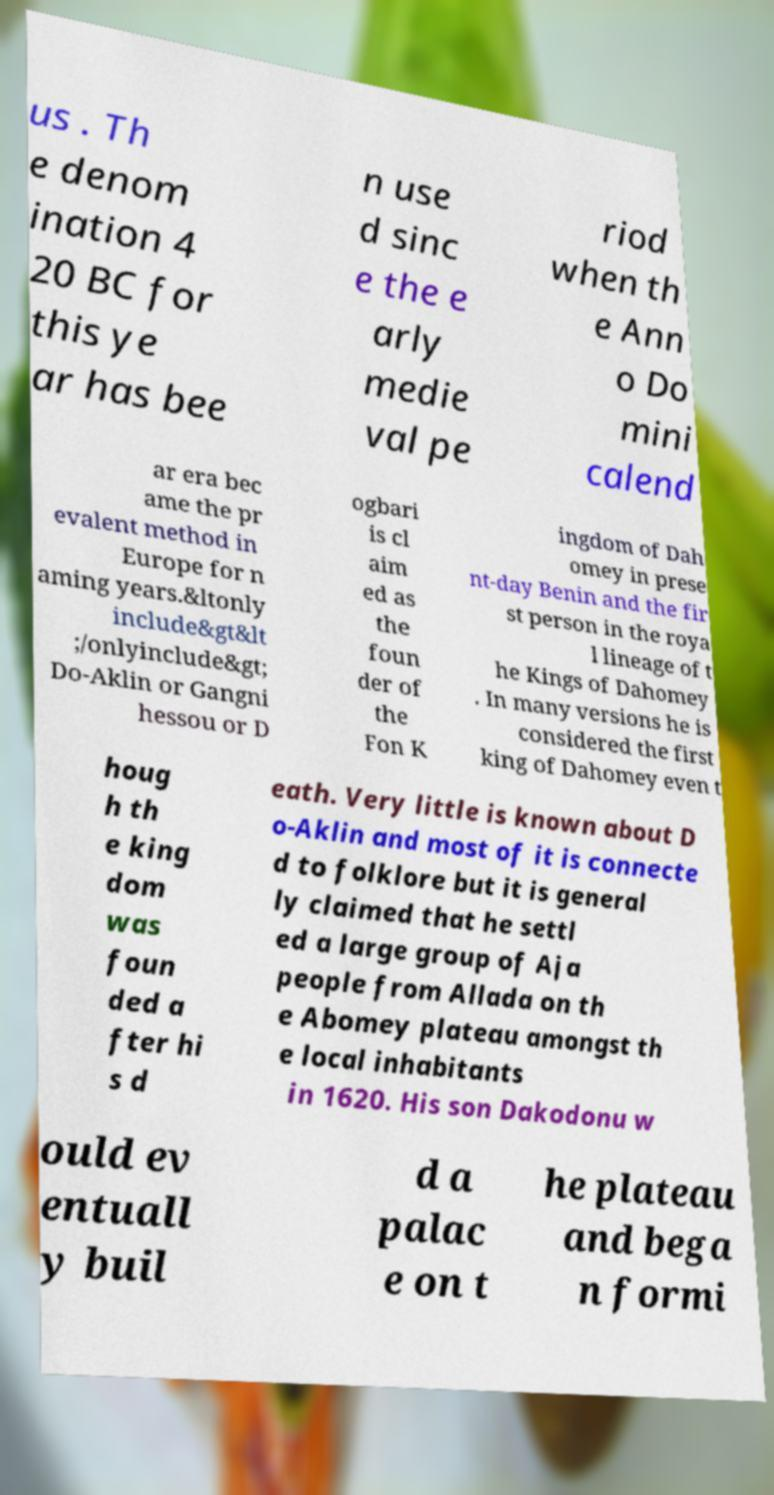What messages or text are displayed in this image? I need them in a readable, typed format. us . Th e denom ination 4 20 BC for this ye ar has bee n use d sinc e the e arly medie val pe riod when th e Ann o Do mini calend ar era bec ame the pr evalent method in Europe for n aming years.&ltonly include&gt&lt ;/onlyinclude&gt; Do-Aklin or Gangni hessou or D ogbari is cl aim ed as the foun der of the Fon K ingdom of Dah omey in prese nt-day Benin and the fir st person in the roya l lineage of t he Kings of Dahomey . In many versions he is considered the first king of Dahomey even t houg h th e king dom was foun ded a fter hi s d eath. Very little is known about D o-Aklin and most of it is connecte d to folklore but it is general ly claimed that he settl ed a large group of Aja people from Allada on th e Abomey plateau amongst th e local inhabitants in 1620. His son Dakodonu w ould ev entuall y buil d a palac e on t he plateau and bega n formi 